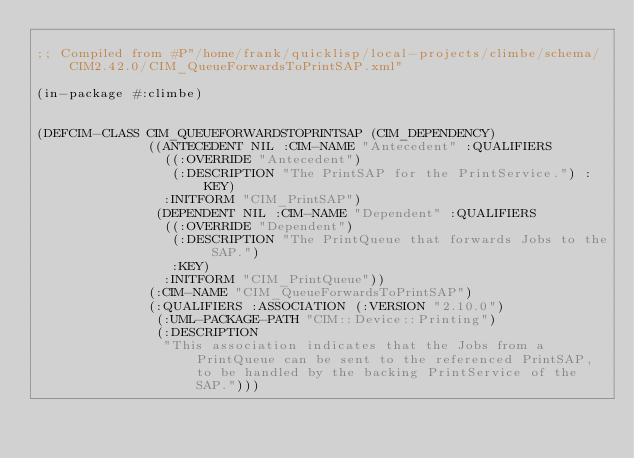<code> <loc_0><loc_0><loc_500><loc_500><_Lisp_>
;; Compiled from #P"/home/frank/quicklisp/local-projects/climbe/schema/CIM2.42.0/CIM_QueueForwardsToPrintSAP.xml"

(in-package #:climbe)


(DEFCIM-CLASS CIM_QUEUEFORWARDSTOPRINTSAP (CIM_DEPENDENCY)
              ((ANTECEDENT NIL :CIM-NAME "Antecedent" :QUALIFIERS
                ((:OVERRIDE "Antecedent")
                 (:DESCRIPTION "The PrintSAP for the PrintService.") :KEY)
                :INITFORM "CIM_PrintSAP")
               (DEPENDENT NIL :CIM-NAME "Dependent" :QUALIFIERS
                ((:OVERRIDE "Dependent")
                 (:DESCRIPTION "The PrintQueue that forwards Jobs to the SAP.")
                 :KEY)
                :INITFORM "CIM_PrintQueue"))
              (:CIM-NAME "CIM_QueueForwardsToPrintSAP")
              (:QUALIFIERS :ASSOCIATION (:VERSION "2.10.0")
               (:UML-PACKAGE-PATH "CIM::Device::Printing")
               (:DESCRIPTION
                "This association indicates that the Jobs from a PrintQueue can be sent to the referenced PrintSAP, to be handled by the backing PrintService of the SAP.")))</code> 